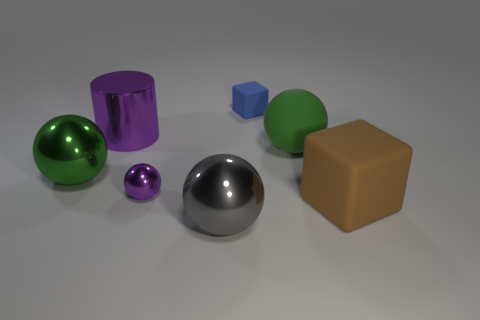What can you tell me about the colors of the objects? The objects vary in color, featuring shades like green, blue, purple, and brown. Each object's singular, vibrant color enhances its individuality within the group. 